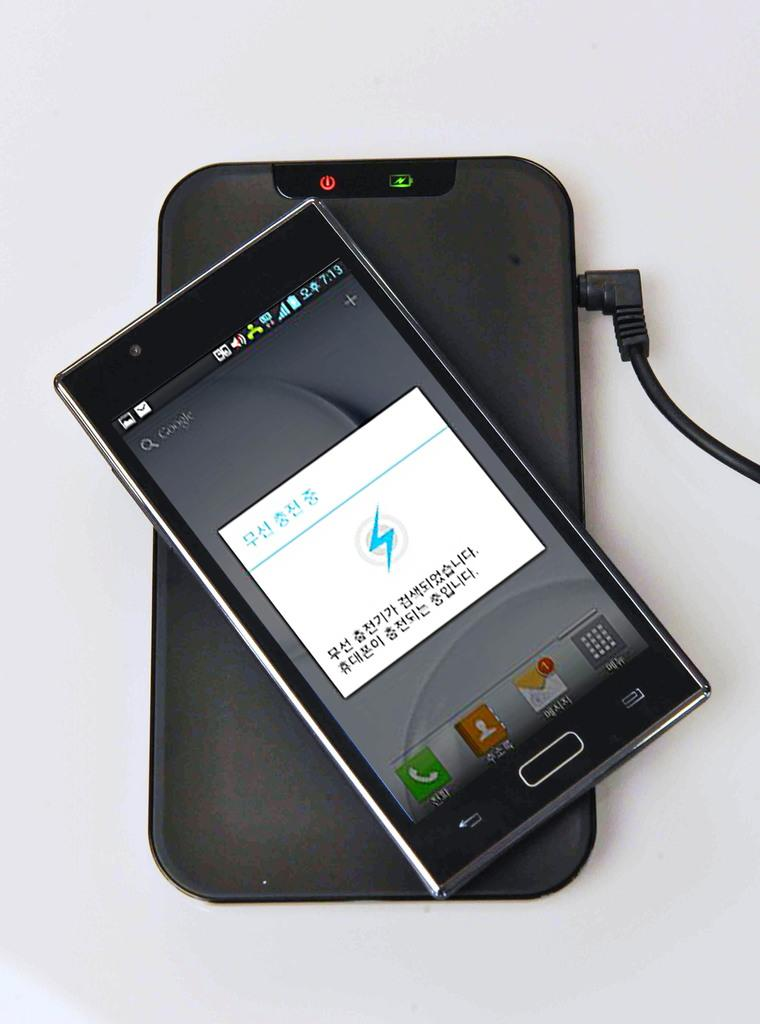What electronic device is present in the image? There is a phone in the image. What color is the object next to the phone? There is a black object in the image. What connects the black object to the phone? There is a black wire in the image. What can be seen in the image that conveys information or a message? There is text or writing in the image. What color is predominant in the background of the image? The background of the image includes white color. How many pigs are visible in the image? There are no pigs present in the image. What type of tiger can be seen in the image? There is no tiger present in the image. 